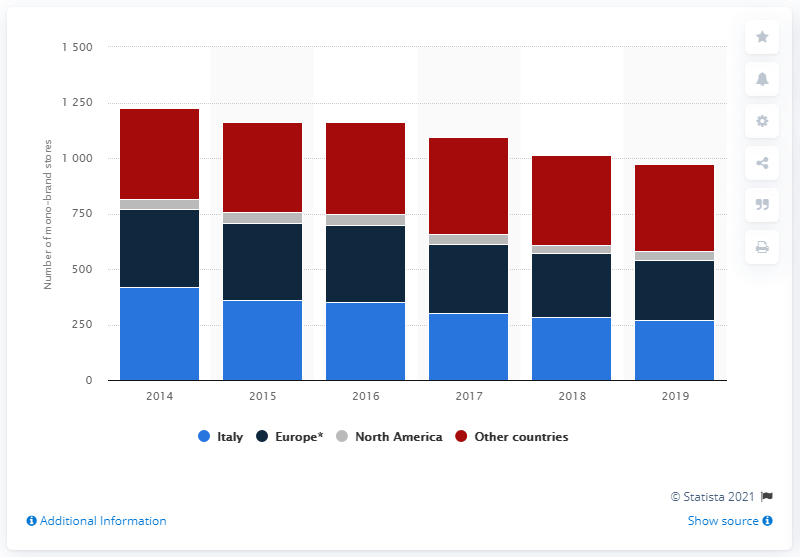Specify some key components in this picture. As of December 31, 2019, there were 272 Geox mono-brand stores in Italy. 